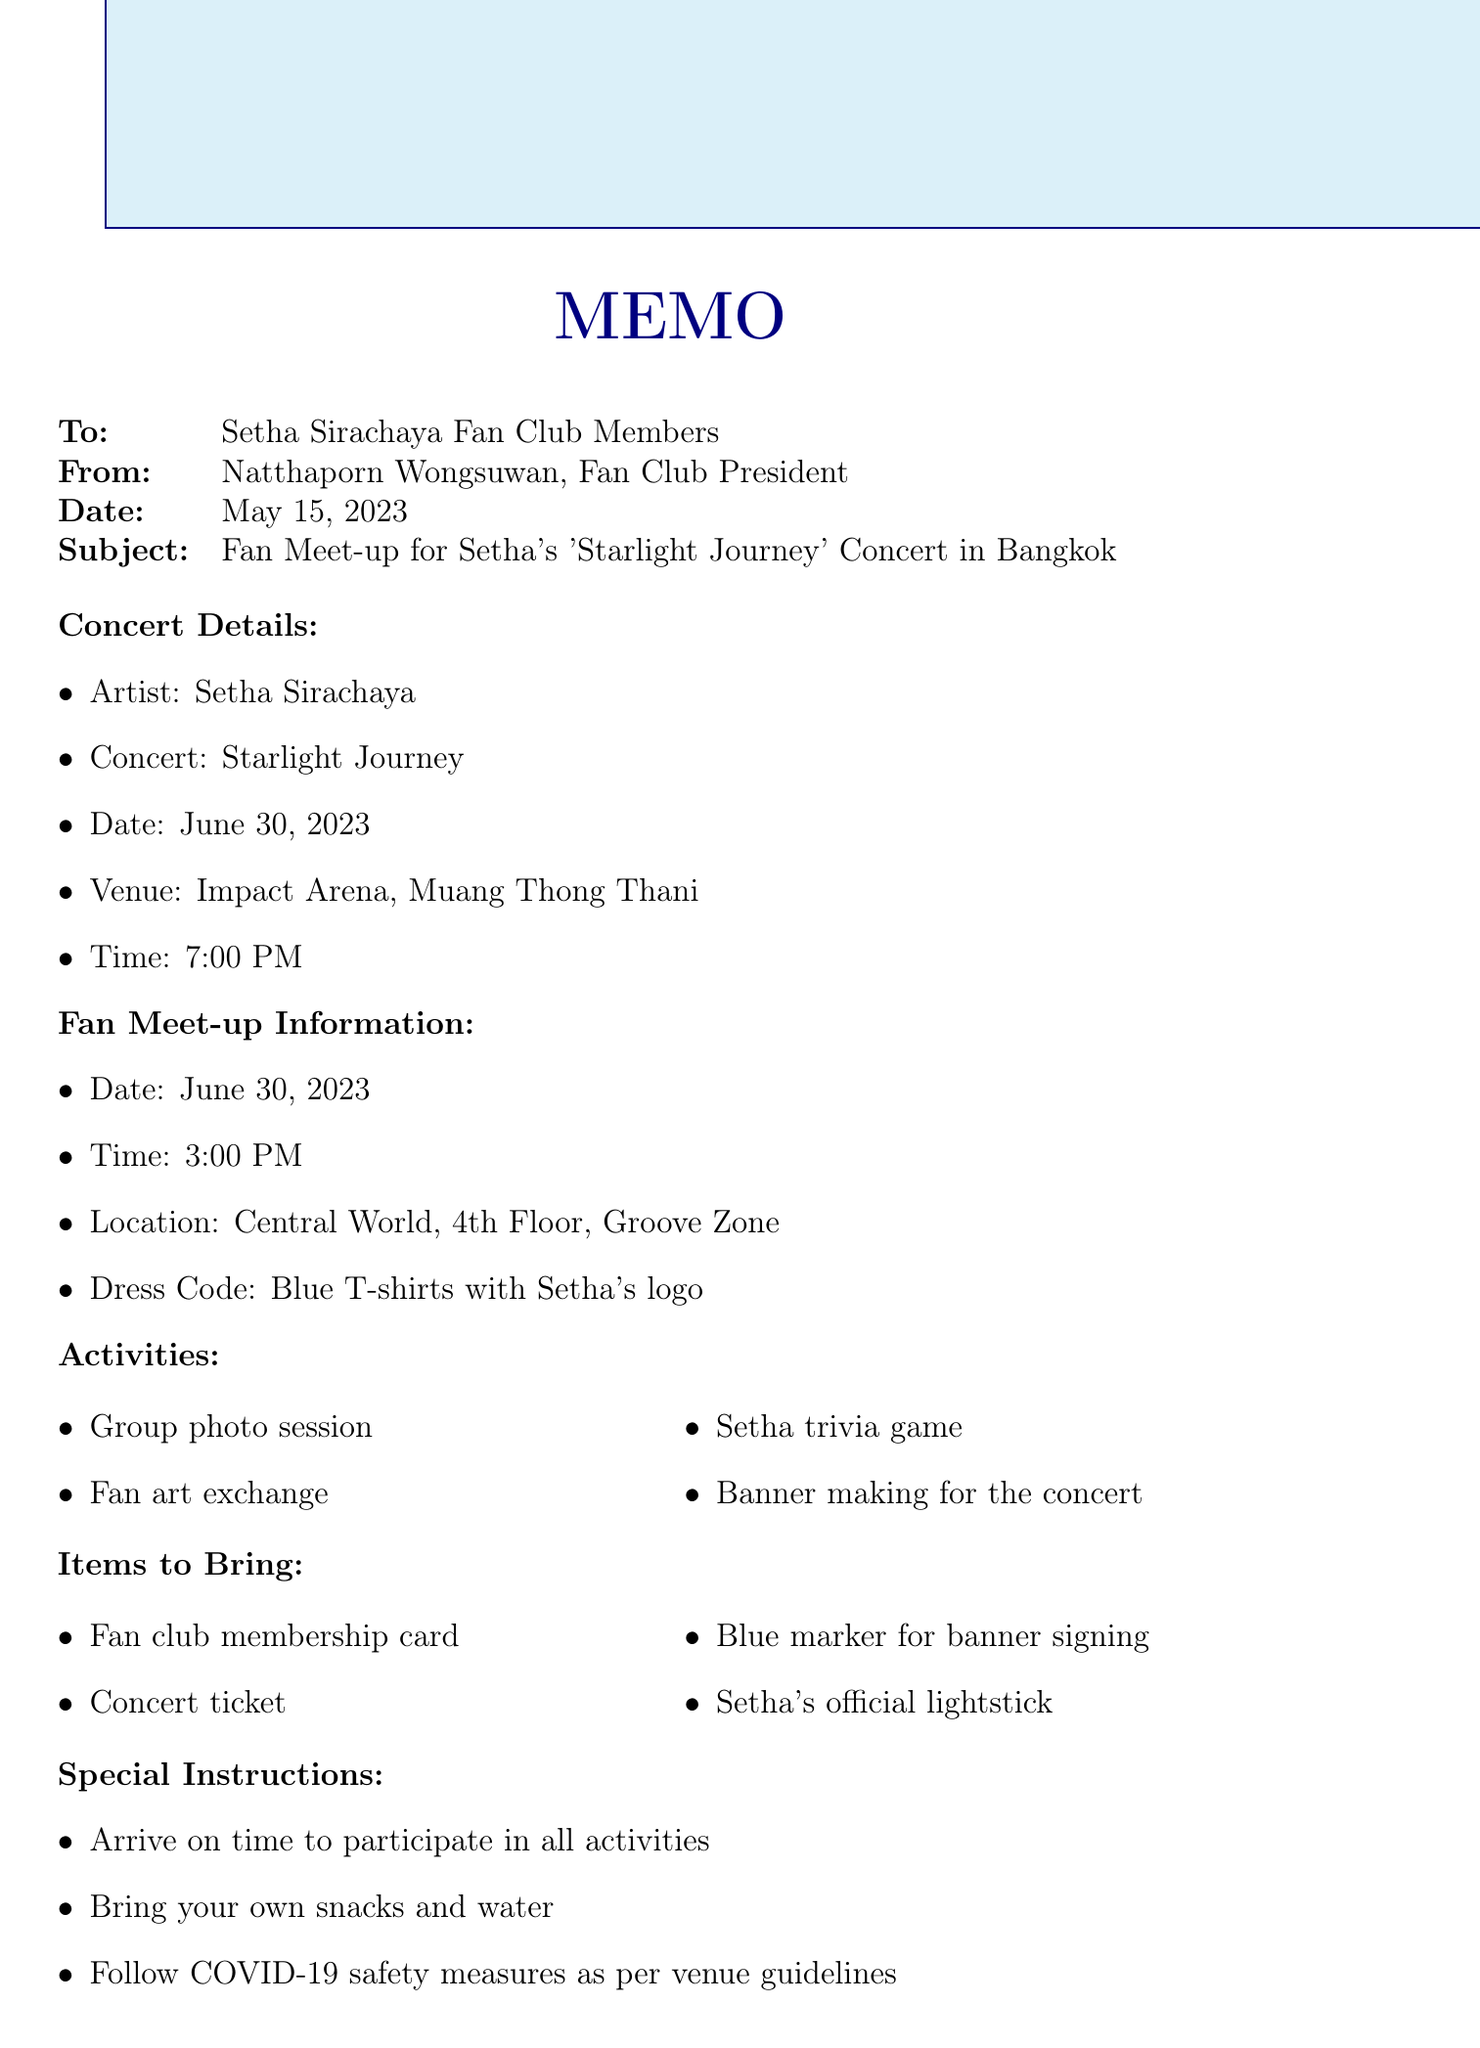What is the date of the fan meet-up? The date of the fan meet-up is mentioned in the document as June 30, 2023.
Answer: June 30, 2023 What time does the concert start? The concert time is clearly specified in the document as 7:00 PM.
Answer: 7:00 PM Where is the meet-up location? The location for the fan meet-up is stated in the document as Central World, 4th Floor, Groove Zone.
Answer: Central World, 4th Floor, Groove Zone Who is the contact person for more information? The document lists Apinya Chaisurivirat as the contact person for the fan club.
Answer: Apinya Chaisurivirat What items should fans bring? The document lists several items to bring, including the fan club membership card, concert ticket, blue marker, and lightstick.
Answer: Fan club membership card, concert ticket, blue marker, lightstick What is the dress code for the meet-up? The dress code is specified in the document as Blue T-shirts with Setha's logo.
Answer: Blue T-shirts with Setha's logo What are the activities planned during the meet-up? The document outlines several activities, including a group photo session, trivia game, and banner making.
Answer: Group photo session, fan art exchange, Setha trivia game, banner making How can fans travel to the concert from the meet-up? The document notes that there is a shuttle bus service available from Central World to Impact Arena.
Answer: Shuttle bus service What should fans do regarding snacks? The document advises fans to bring their own snacks and water.
Answer: Bring your own snacks and water 